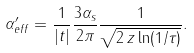<formula> <loc_0><loc_0><loc_500><loc_500>\alpha _ { e f f } ^ { \prime } = \frac { 1 } { | t | } \frac { 3 \alpha _ { s } } { 2 \pi } \frac { 1 } { \sqrt { 2 \, z \ln ( 1 / \tau ) } } .</formula> 